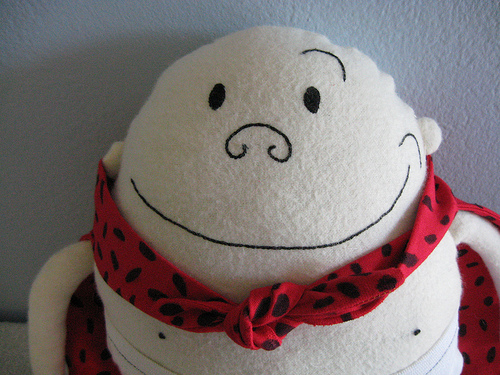<image>
Is there a wall in front of the doll? No. The wall is not in front of the doll. The spatial positioning shows a different relationship between these objects. 